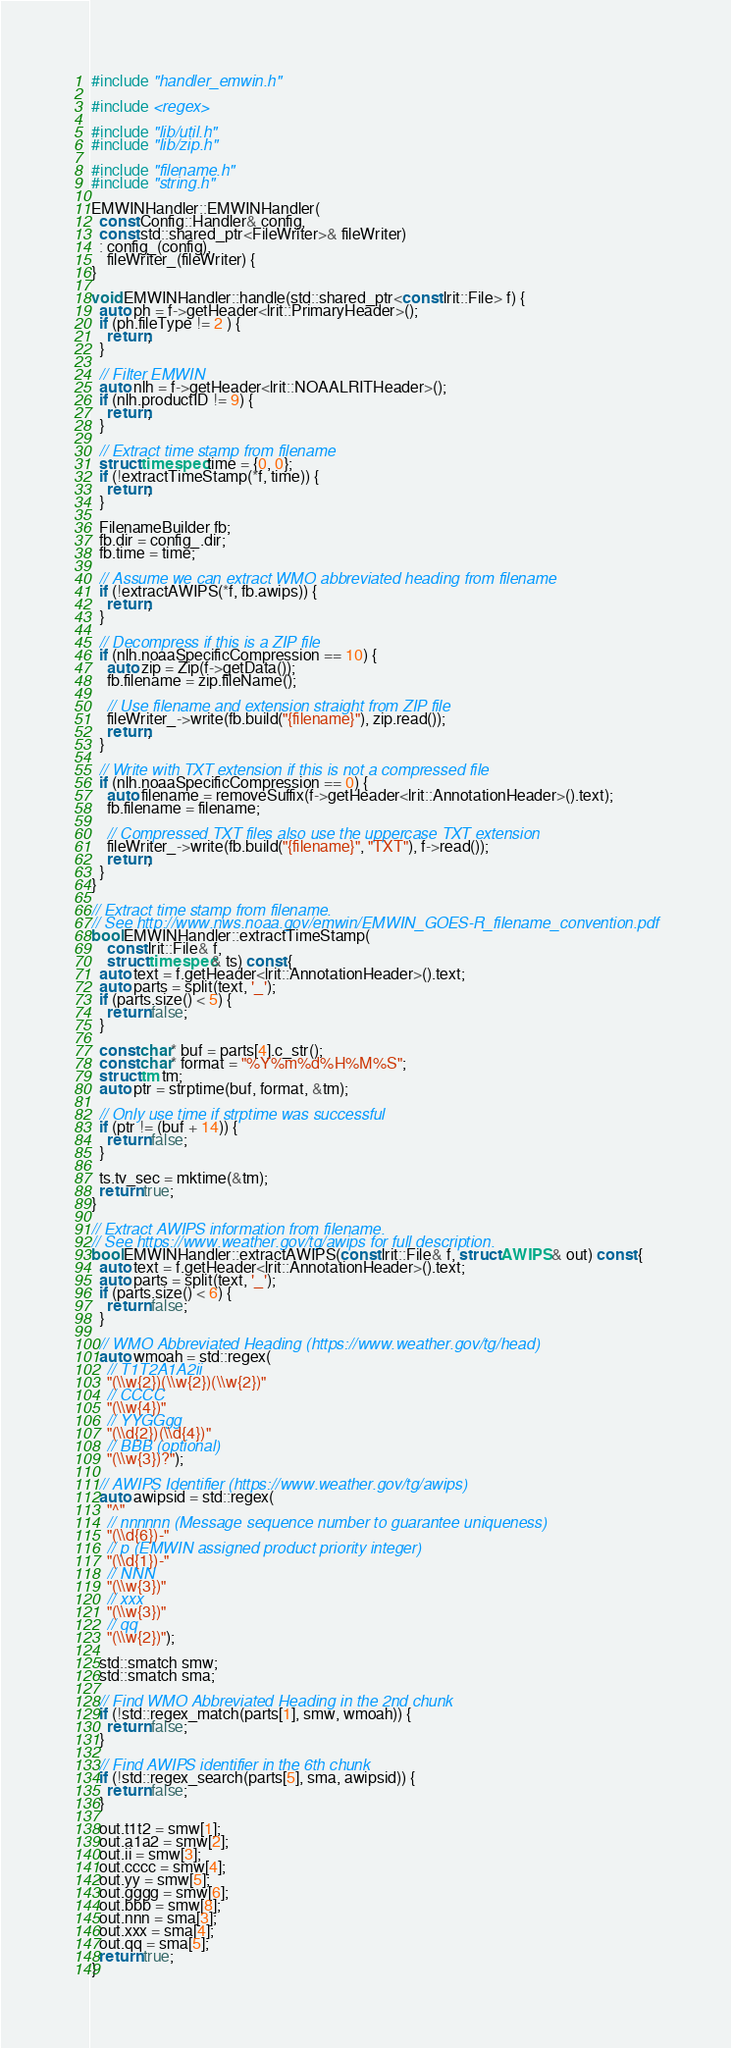Convert code to text. <code><loc_0><loc_0><loc_500><loc_500><_C++_>#include "handler_emwin.h"

#include <regex>

#include "lib/util.h"
#include "lib/zip.h"

#include "filename.h"
#include "string.h"

EMWINHandler::EMWINHandler(
  const Config::Handler& config,
  const std::shared_ptr<FileWriter>& fileWriter)
  : config_(config),
    fileWriter_(fileWriter) {
}

void EMWINHandler::handle(std::shared_ptr<const lrit::File> f) {
  auto ph = f->getHeader<lrit::PrimaryHeader>();
  if (ph.fileType != 2 ) {
    return;
  }

  // Filter EMWIN
  auto nlh = f->getHeader<lrit::NOAALRITHeader>();
  if (nlh.productID != 9) {
    return;
  }

  // Extract time stamp from filename
  struct timespec time = {0, 0};
  if (!extractTimeStamp(*f, time)) {
    return;
  }

  FilenameBuilder fb;
  fb.dir = config_.dir;
  fb.time = time;

  // Assume we can extract WMO abbreviated heading from filename
  if (!extractAWIPS(*f, fb.awips)) {
    return;
  }

  // Decompress if this is a ZIP file
  if (nlh.noaaSpecificCompression == 10) {
    auto zip = Zip(f->getData());
    fb.filename = zip.fileName();

    // Use filename and extension straight from ZIP file
    fileWriter_->write(fb.build("{filename}"), zip.read());
    return;
  }

  // Write with TXT extension if this is not a compressed file
  if (nlh.noaaSpecificCompression == 0) {
    auto filename = removeSuffix(f->getHeader<lrit::AnnotationHeader>().text);
    fb.filename = filename;

    // Compressed TXT files also use the uppercase TXT extension
    fileWriter_->write(fb.build("{filename}", "TXT"), f->read());
    return;
  }
}

// Extract time stamp from filename.
// See http://www.nws.noaa.gov/emwin/EMWIN_GOES-R_filename_convention.pdf
bool EMWINHandler::extractTimeStamp(
    const lrit::File& f,
    struct timespec& ts) const {
  auto text = f.getHeader<lrit::AnnotationHeader>().text;
  auto parts = split(text, '_');
  if (parts.size() < 5) {
    return false;
  }

  const char* buf = parts[4].c_str();
  const char* format = "%Y%m%d%H%M%S";
  struct tm tm;
  auto ptr = strptime(buf, format, &tm);

  // Only use time if strptime was successful
  if (ptr != (buf + 14)) {
    return false;
  }

  ts.tv_sec = mktime(&tm);
  return true;
}

// Extract AWIPS information from filename.
// See https://www.weather.gov/tg/awips for full description.
bool EMWINHandler::extractAWIPS(const lrit::File& f, struct AWIPS& out) const {
  auto text = f.getHeader<lrit::AnnotationHeader>().text;
  auto parts = split(text, '_');
  if (parts.size() < 6) {
    return false;
  }

  // WMO Abbreviated Heading (https://www.weather.gov/tg/head)
  auto wmoah = std::regex(
    // T1T2A1A2ii
    "(\\w{2})(\\w{2})(\\w{2})"
    // CCCC
    "(\\w{4})"
    // YYGGgg
    "(\\d{2})(\\d{4})"
    // BBB (optional)
    "(\\w{3})?");

  // AWIPS Identifier (https://www.weather.gov/tg/awips)
  auto awipsid = std::regex(
    "^"
    // nnnnnn (Message sequence number to guarantee uniqueness)
    "(\\d{6})-"
    // p (EMWIN assigned product priority integer)
    "(\\d{1})-"
    // NNN
    "(\\w{3})"
    // xxx
    "(\\w{3})"
    // qq
    "(\\w{2})");

  std::smatch smw;
  std::smatch sma;

  // Find WMO Abbreviated Heading in the 2nd chunk
  if (!std::regex_match(parts[1], smw, wmoah)) {
    return false;
  }

  // Find AWIPS identifier in the 6th chunk
  if (!std::regex_search(parts[5], sma, awipsid)) {
    return false;
  }

  out.t1t2 = smw[1];
  out.a1a2 = smw[2];
  out.ii = smw[3];
  out.cccc = smw[4];
  out.yy = smw[5];
  out.gggg = smw[6];
  out.bbb = smw[8];
  out.nnn = sma[3];
  out.xxx = sma[4];
  out.qq = sma[5];
  return true;
}
</code> 